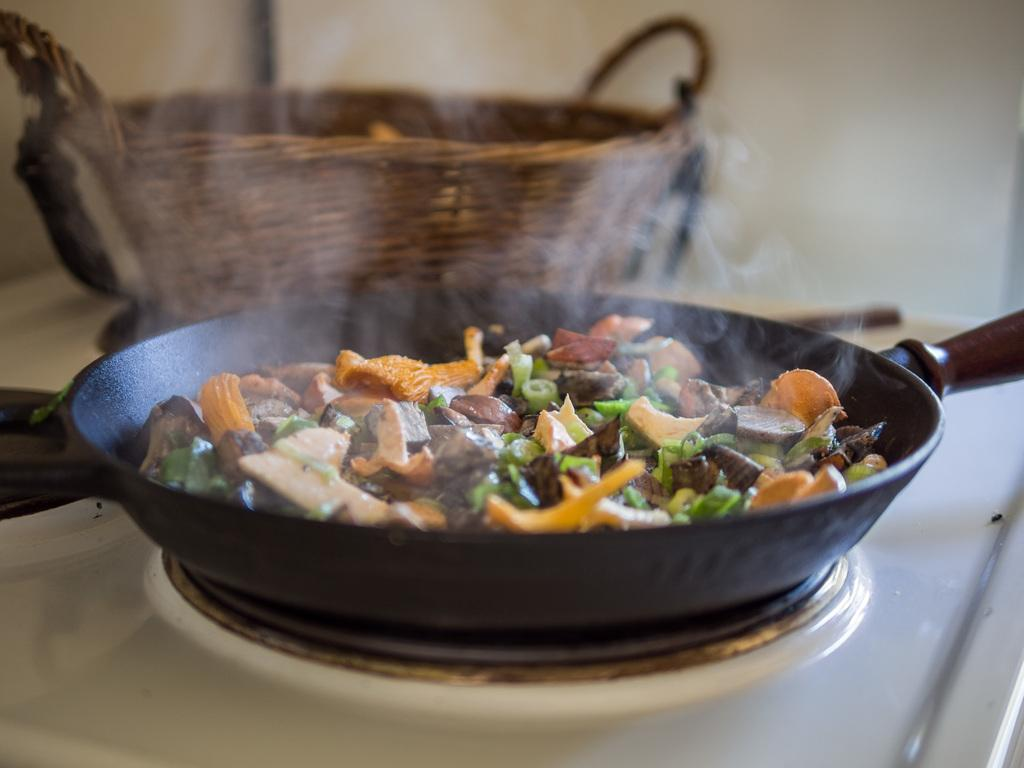What is on the pan that is visible in the image? There is food on a pan in the image. Where is the pan located in the image? The pan is in the center of the image. What can be seen in the background of the image? There is a basket in the background of the image. How many hills can be seen in the image? There are no hills visible in the image. What type of pencil is being used to draw on the pan? There is no pencil present in the image, and the pan is not being used for drawing. 